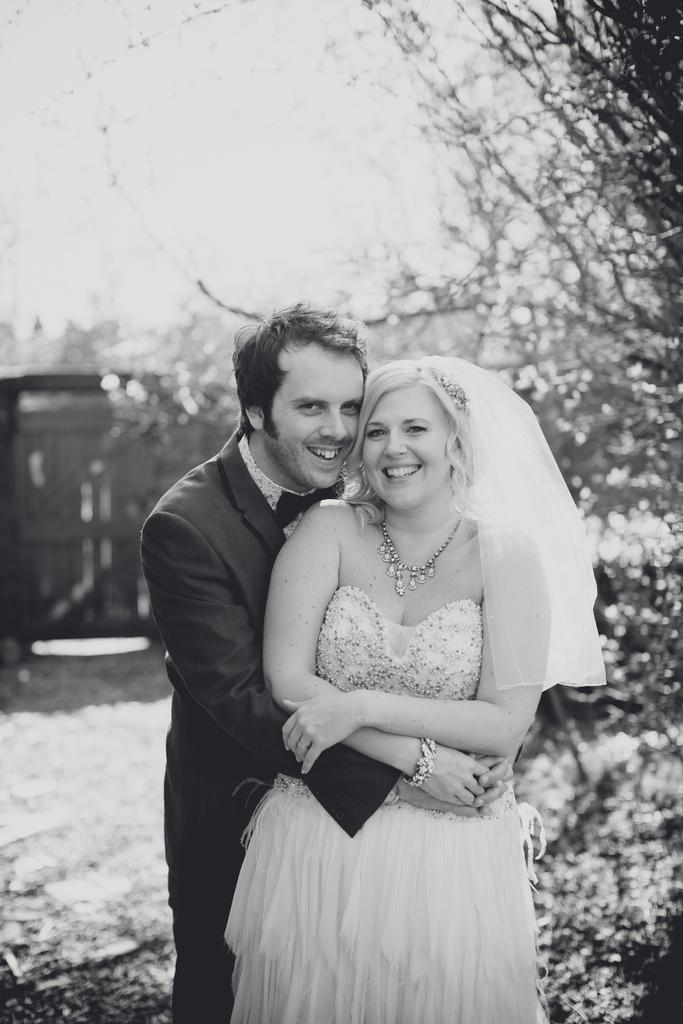How many people are in the image? There is a man and a woman in the image. What are the man and woman doing in the image? Both the man and woman are standing and smiling. What can be seen in the background of the image? There are trees and the sky is visible in the background of the image. How would you describe the quality of the background? The background appears blurry. Can you see any feet in the image? There is no specific mention of feet in the image, so it cannot be confirmed whether they are visible or not. What type of kite is being flown by the man in the image? There is no kite present in the image. 